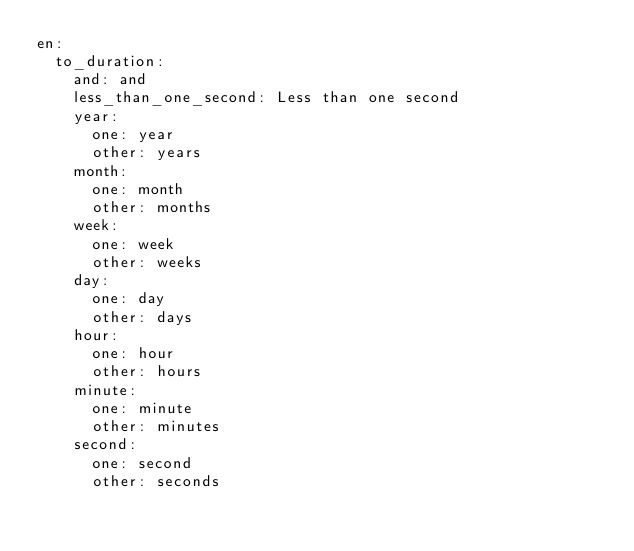Convert code to text. <code><loc_0><loc_0><loc_500><loc_500><_YAML_>en:
  to_duration:
    and: and
    less_than_one_second: Less than one second
    year:
      one: year
      other: years
    month:
      one: month
      other: months
    week:
      one: week
      other: weeks
    day:
      one: day
      other: days
    hour:
      one: hour
      other: hours
    minute:
      one: minute
      other: minutes
    second:
      one: second
      other: seconds
</code> 